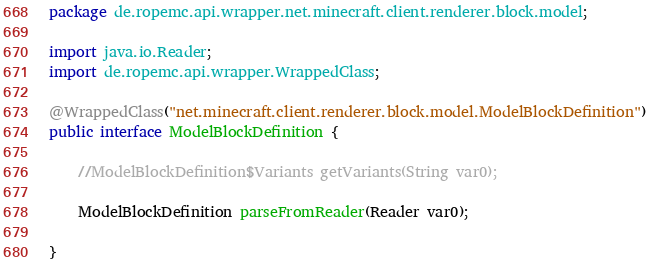Convert code to text. <code><loc_0><loc_0><loc_500><loc_500><_Java_>package de.ropemc.api.wrapper.net.minecraft.client.renderer.block.model;

import java.io.Reader;
import de.ropemc.api.wrapper.WrappedClass;

@WrappedClass("net.minecraft.client.renderer.block.model.ModelBlockDefinition")
public interface ModelBlockDefinition {

    //ModelBlockDefinition$Variants getVariants(String var0);

    ModelBlockDefinition parseFromReader(Reader var0);

}
</code> 